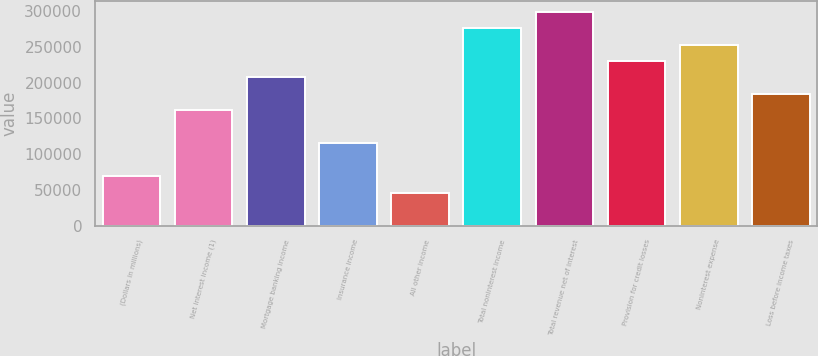Convert chart. <chart><loc_0><loc_0><loc_500><loc_500><bar_chart><fcel>(Dollars in millions)<fcel>Net interest income (1)<fcel>Mortgage banking income<fcel>Insurance income<fcel>All other income<fcel>Total noninterest income<fcel>Total revenue net of interest<fcel>Provision for credit losses<fcel>Noninterest expense<fcel>Loss before income taxes<nl><fcel>69072<fcel>161165<fcel>207211<fcel>115118<fcel>46048.8<fcel>276280<fcel>299303<fcel>230234<fcel>253257<fcel>184188<nl></chart> 